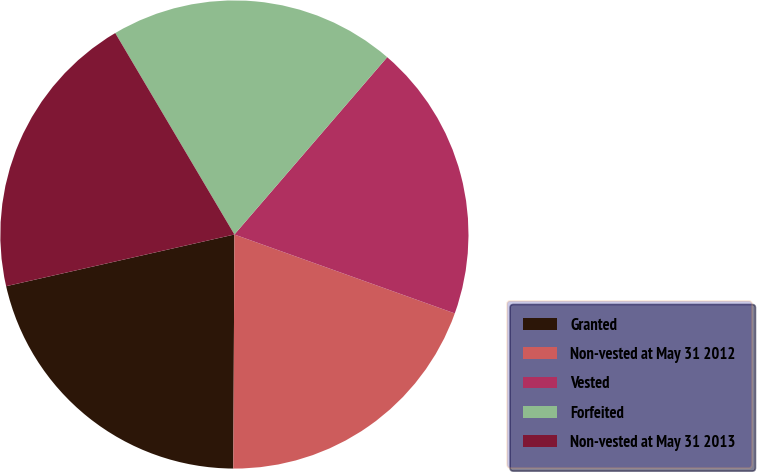<chart> <loc_0><loc_0><loc_500><loc_500><pie_chart><fcel>Granted<fcel>Non-vested at May 31 2012<fcel>Vested<fcel>Forfeited<fcel>Non-vested at May 31 2013<nl><fcel>21.38%<fcel>19.6%<fcel>19.15%<fcel>19.82%<fcel>20.04%<nl></chart> 